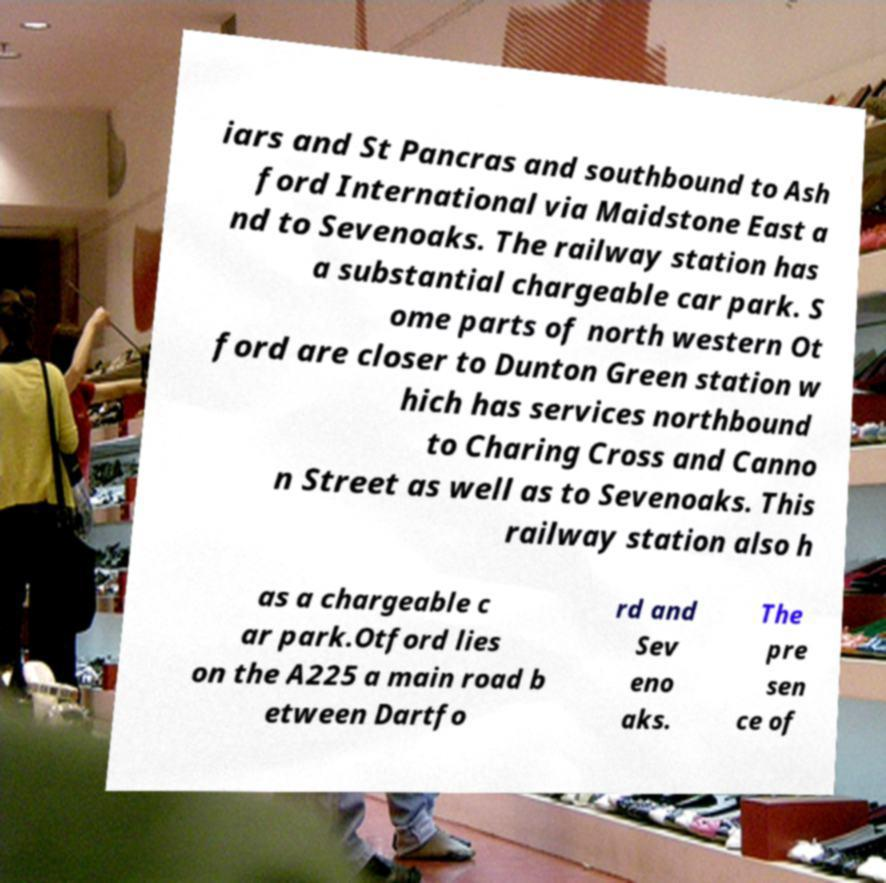Can you accurately transcribe the text from the provided image for me? iars and St Pancras and southbound to Ash ford International via Maidstone East a nd to Sevenoaks. The railway station has a substantial chargeable car park. S ome parts of north western Ot ford are closer to Dunton Green station w hich has services northbound to Charing Cross and Canno n Street as well as to Sevenoaks. This railway station also h as a chargeable c ar park.Otford lies on the A225 a main road b etween Dartfo rd and Sev eno aks. The pre sen ce of 